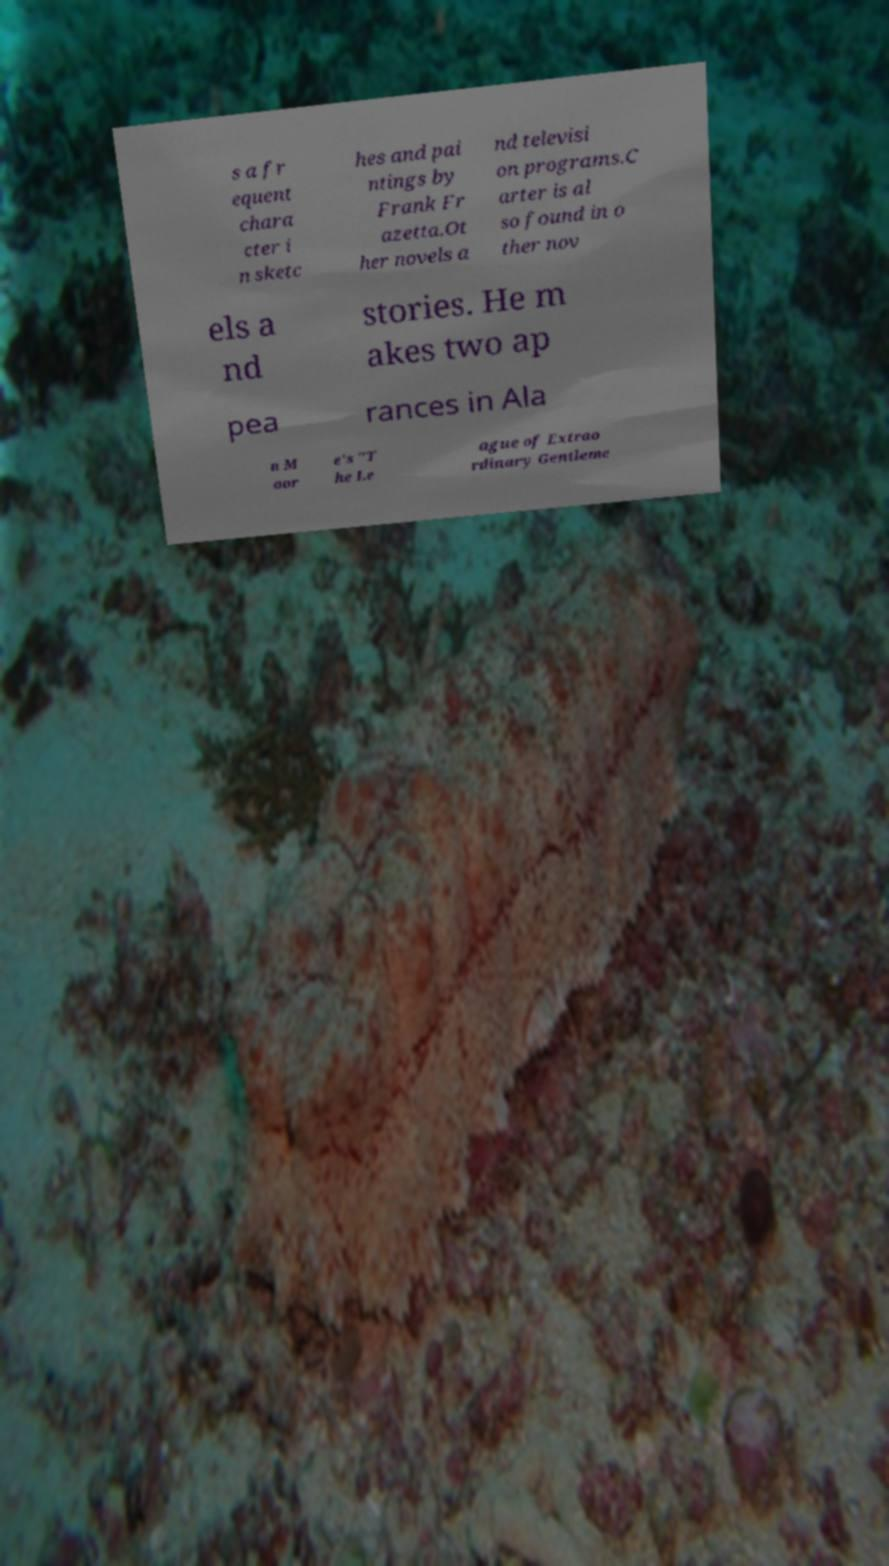Can you accurately transcribe the text from the provided image for me? s a fr equent chara cter i n sketc hes and pai ntings by Frank Fr azetta.Ot her novels a nd televisi on programs.C arter is al so found in o ther nov els a nd stories. He m akes two ap pea rances in Ala n M oor e's "T he Le ague of Extrao rdinary Gentleme 